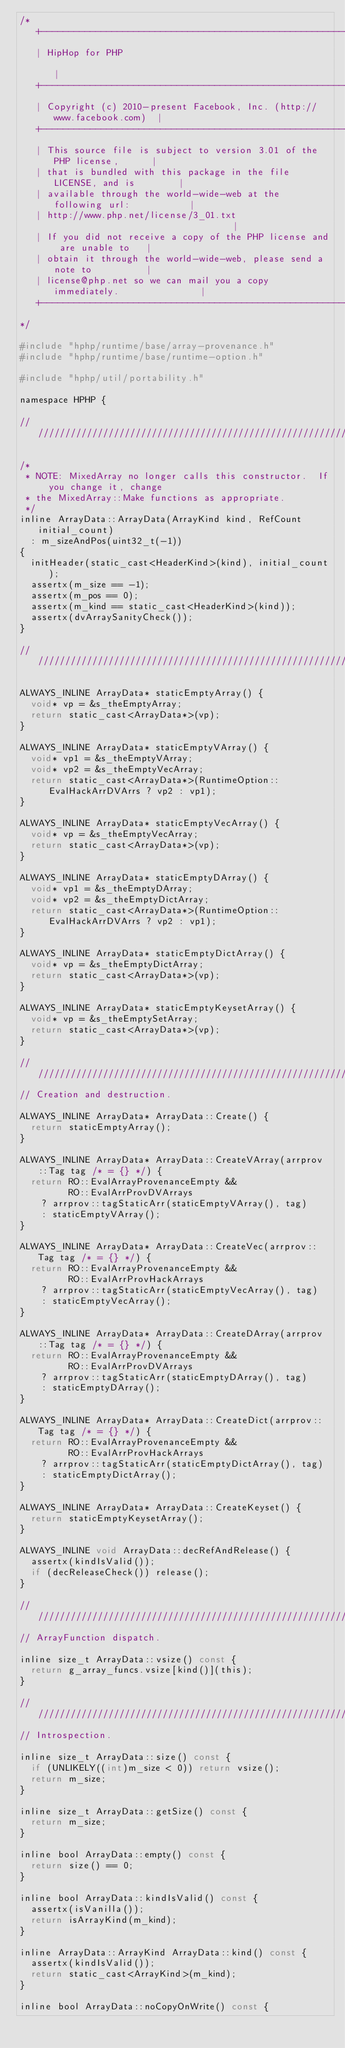<code> <loc_0><loc_0><loc_500><loc_500><_C_>/*
   +----------------------------------------------------------------------+
   | HipHop for PHP                                                       |
   +----------------------------------------------------------------------+
   | Copyright (c) 2010-present Facebook, Inc. (http://www.facebook.com)  |
   +----------------------------------------------------------------------+
   | This source file is subject to version 3.01 of the PHP license,      |
   | that is bundled with this package in the file LICENSE, and is        |
   | available through the world-wide-web at the following url:           |
   | http://www.php.net/license/3_01.txt                                  |
   | If you did not receive a copy of the PHP license and are unable to   |
   | obtain it through the world-wide-web, please send a note to          |
   | license@php.net so we can mail you a copy immediately.               |
   +----------------------------------------------------------------------+
*/

#include "hphp/runtime/base/array-provenance.h"
#include "hphp/runtime/base/runtime-option.h"

#include "hphp/util/portability.h"

namespace HPHP {

///////////////////////////////////////////////////////////////////////////////

/*
 * NOTE: MixedArray no longer calls this constructor.  If you change it, change
 * the MixedArray::Make functions as appropriate.
 */
inline ArrayData::ArrayData(ArrayKind kind, RefCount initial_count)
  : m_sizeAndPos(uint32_t(-1))
{
  initHeader(static_cast<HeaderKind>(kind), initial_count);
  assertx(m_size == -1);
  assertx(m_pos == 0);
  assertx(m_kind == static_cast<HeaderKind>(kind));
  assertx(dvArraySanityCheck());
}

///////////////////////////////////////////////////////////////////////////////

ALWAYS_INLINE ArrayData* staticEmptyArray() {
  void* vp = &s_theEmptyArray;
  return static_cast<ArrayData*>(vp);
}

ALWAYS_INLINE ArrayData* staticEmptyVArray() {
  void* vp1 = &s_theEmptyVArray;
  void* vp2 = &s_theEmptyVecArray;
  return static_cast<ArrayData*>(RuntimeOption::EvalHackArrDVArrs ? vp2 : vp1);
}

ALWAYS_INLINE ArrayData* staticEmptyVecArray() {
  void* vp = &s_theEmptyVecArray;
  return static_cast<ArrayData*>(vp);
}

ALWAYS_INLINE ArrayData* staticEmptyDArray() {
  void* vp1 = &s_theEmptyDArray;
  void* vp2 = &s_theEmptyDictArray;
  return static_cast<ArrayData*>(RuntimeOption::EvalHackArrDVArrs ? vp2 : vp1);
}

ALWAYS_INLINE ArrayData* staticEmptyDictArray() {
  void* vp = &s_theEmptyDictArray;
  return static_cast<ArrayData*>(vp);
}

ALWAYS_INLINE ArrayData* staticEmptyKeysetArray() {
  void* vp = &s_theEmptySetArray;
  return static_cast<ArrayData*>(vp);
}

///////////////////////////////////////////////////////////////////////////////
// Creation and destruction.

ALWAYS_INLINE ArrayData* ArrayData::Create() {
  return staticEmptyArray();
}

ALWAYS_INLINE ArrayData* ArrayData::CreateVArray(arrprov::Tag tag /* = {} */) {
  return RO::EvalArrayProvenanceEmpty &&
         RO::EvalArrProvDVArrays
    ? arrprov::tagStaticArr(staticEmptyVArray(), tag)
    : staticEmptyVArray();
}

ALWAYS_INLINE ArrayData* ArrayData::CreateVec(arrprov::Tag tag /* = {} */) {
  return RO::EvalArrayProvenanceEmpty &&
         RO::EvalArrProvHackArrays
    ? arrprov::tagStaticArr(staticEmptyVecArray(), tag)
    : staticEmptyVecArray();
}

ALWAYS_INLINE ArrayData* ArrayData::CreateDArray(arrprov::Tag tag /* = {} */) {
  return RO::EvalArrayProvenanceEmpty &&
         RO::EvalArrProvDVArrays
    ? arrprov::tagStaticArr(staticEmptyDArray(), tag)
    : staticEmptyDArray();
}

ALWAYS_INLINE ArrayData* ArrayData::CreateDict(arrprov::Tag tag /* = {} */) {
  return RO::EvalArrayProvenanceEmpty &&
         RO::EvalArrProvHackArrays
    ? arrprov::tagStaticArr(staticEmptyDictArray(), tag)
    : staticEmptyDictArray();
}

ALWAYS_INLINE ArrayData* ArrayData::CreateKeyset() {
  return staticEmptyKeysetArray();
}

ALWAYS_INLINE void ArrayData::decRefAndRelease() {
  assertx(kindIsValid());
  if (decReleaseCheck()) release();
}

///////////////////////////////////////////////////////////////////////////////
// ArrayFunction dispatch.

inline size_t ArrayData::vsize() const {
  return g_array_funcs.vsize[kind()](this);
}

///////////////////////////////////////////////////////////////////////////////
// Introspection.

inline size_t ArrayData::size() const {
  if (UNLIKELY((int)m_size < 0)) return vsize();
  return m_size;
}

inline size_t ArrayData::getSize() const {
  return m_size;
}

inline bool ArrayData::empty() const {
  return size() == 0;
}

inline bool ArrayData::kindIsValid() const {
  assertx(isVanilla());
  return isArrayKind(m_kind);
}

inline ArrayData::ArrayKind ArrayData::kind() const {
  assertx(kindIsValid());
  return static_cast<ArrayKind>(m_kind);
}

inline bool ArrayData::noCopyOnWrite() const {</code> 